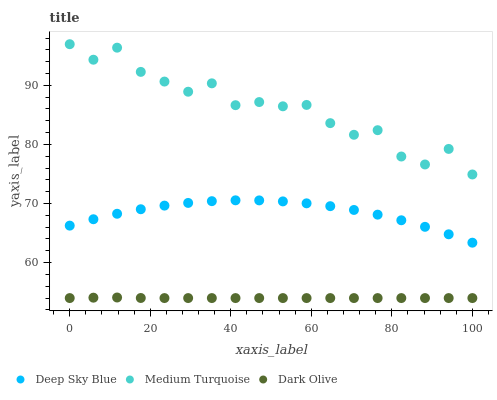Does Dark Olive have the minimum area under the curve?
Answer yes or no. Yes. Does Medium Turquoise have the maximum area under the curve?
Answer yes or no. Yes. Does Deep Sky Blue have the minimum area under the curve?
Answer yes or no. No. Does Deep Sky Blue have the maximum area under the curve?
Answer yes or no. No. Is Dark Olive the smoothest?
Answer yes or no. Yes. Is Medium Turquoise the roughest?
Answer yes or no. Yes. Is Deep Sky Blue the smoothest?
Answer yes or no. No. Is Deep Sky Blue the roughest?
Answer yes or no. No. Does Dark Olive have the lowest value?
Answer yes or no. Yes. Does Deep Sky Blue have the lowest value?
Answer yes or no. No. Does Medium Turquoise have the highest value?
Answer yes or no. Yes. Does Deep Sky Blue have the highest value?
Answer yes or no. No. Is Dark Olive less than Medium Turquoise?
Answer yes or no. Yes. Is Medium Turquoise greater than Dark Olive?
Answer yes or no. Yes. Does Dark Olive intersect Medium Turquoise?
Answer yes or no. No. 